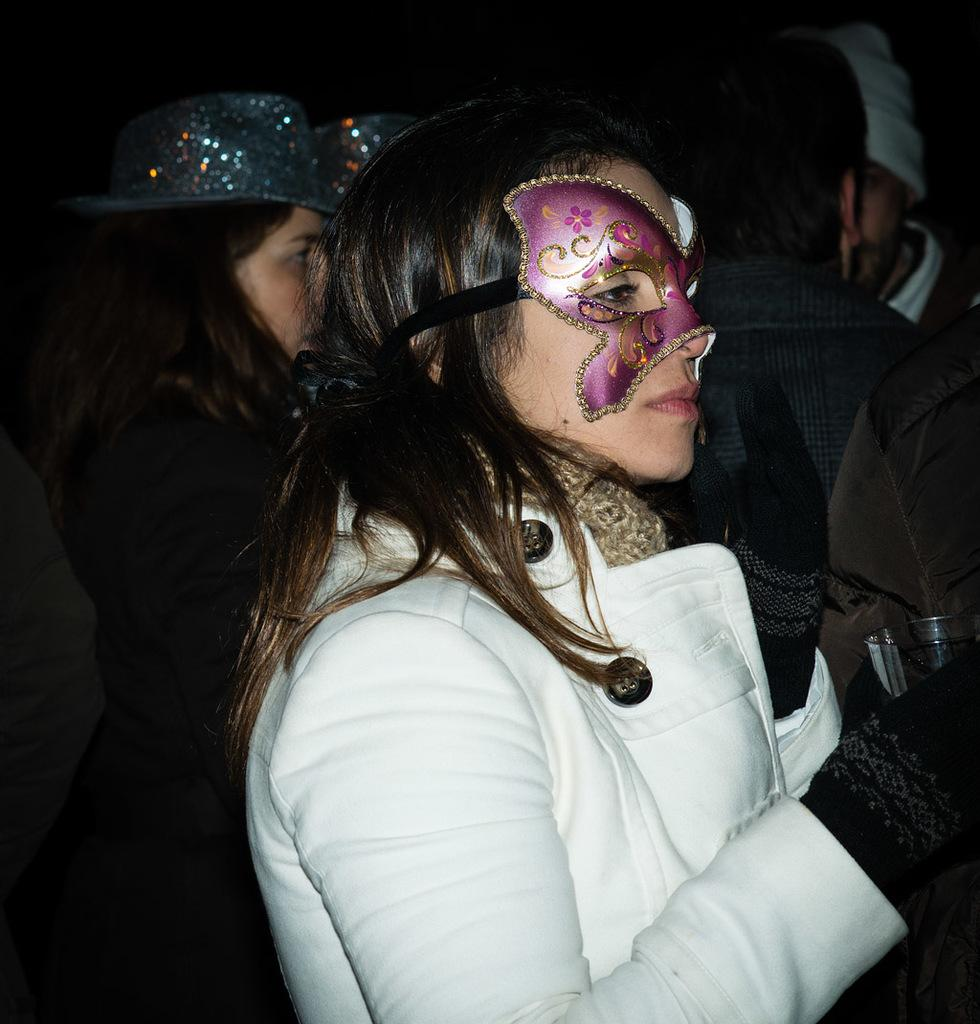What is happening in the image? There are people standing in the image. Can you describe the background of the image? The background of the image is dark. What type of underwear is the person on the left wearing in the image? There is no information about the person's underwear in the image, as it is not visible or mentioned in the provided facts. 